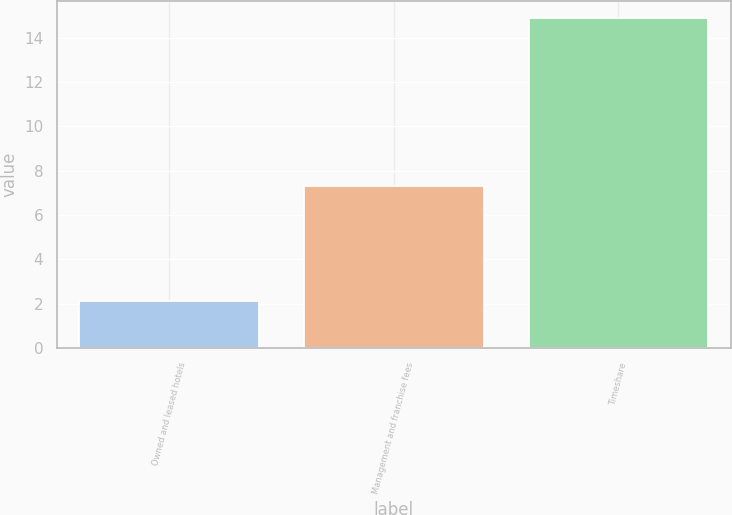Convert chart. <chart><loc_0><loc_0><loc_500><loc_500><bar_chart><fcel>Owned and leased hotels<fcel>Management and franchise fees<fcel>Timeshare<nl><fcel>2.1<fcel>7.3<fcel>14.9<nl></chart> 